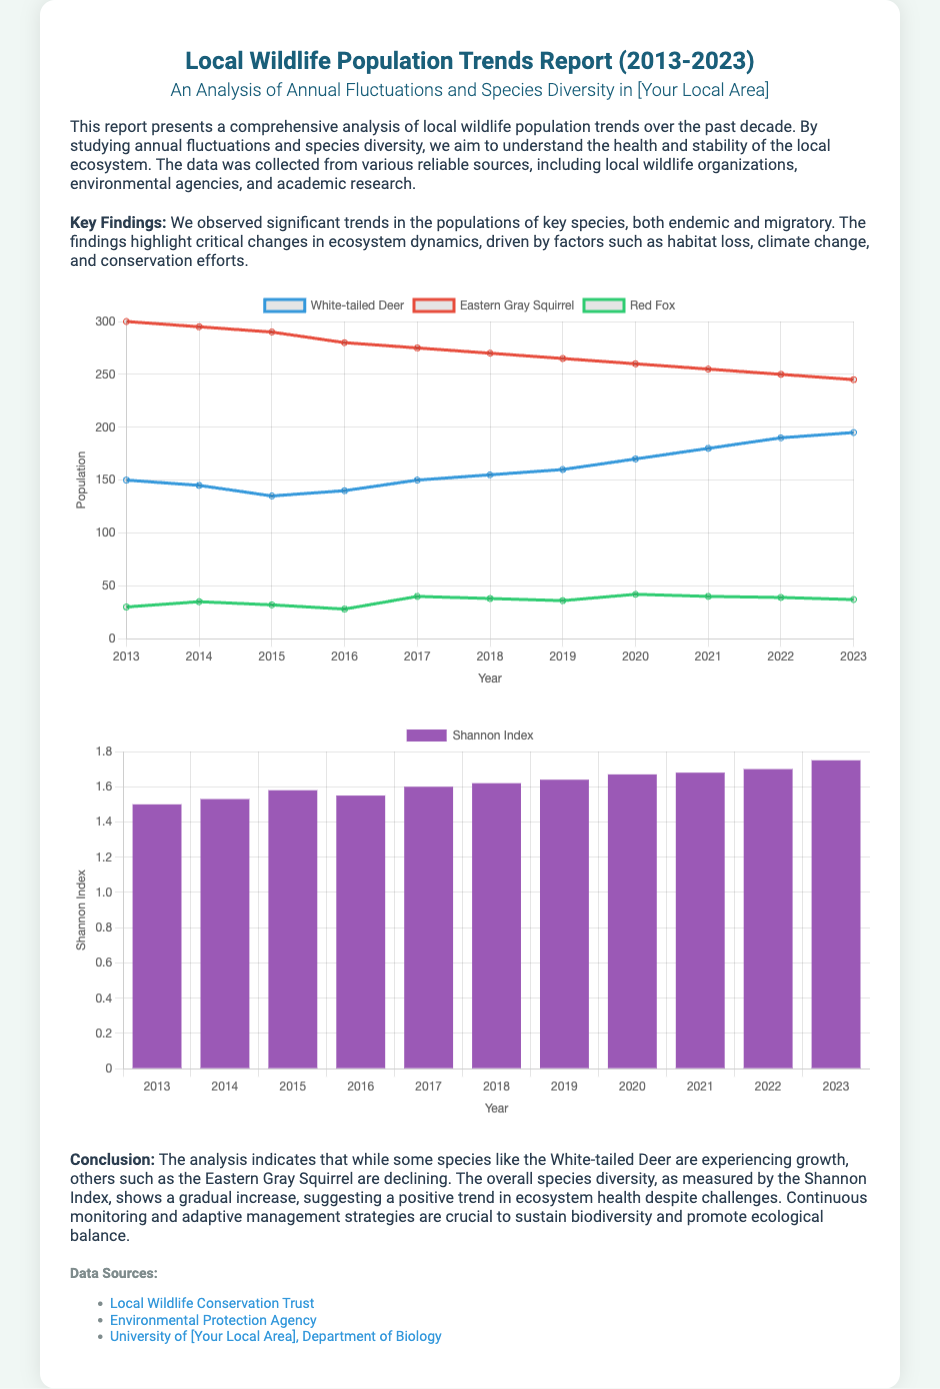What is the title of the report? The title of the report is provided in the document header.
Answer: Local Wildlife Population Trends Report (2013-2023) What years does the report analyze? The report analyzes wildlife population trends over a decade, specifically from 2013 to 2023.
Answer: 2013-2023 Which species is experiencing population growth? The report mentions the growth of certain species, which can be found in the conclusions.
Answer: White-tailed Deer What is the Shannon Index for 2023? The Shannon Index for 2023 is mentioned in the diversity chart of the document.
Answer: 1.75 Which local wildlife organization is cited? The report lists several data sources, including local wildlife organizations, in the sources section.
Answer: Local Wildlife Conservation Trust How many key species are mentioned in the report? The report discusses trends in the populations of several key species as noted in the key findings section.
Answer: Three What type of chart represents the population fluctuations? The type of chart used to represent population fluctuations is specified in the script section of the code.
Answer: Line chart In which year did the Eastern Gray Squirrel peak? The data for the Eastern Gray Squirrel's population trends allows us to determine its peak year.
Answer: 2013 